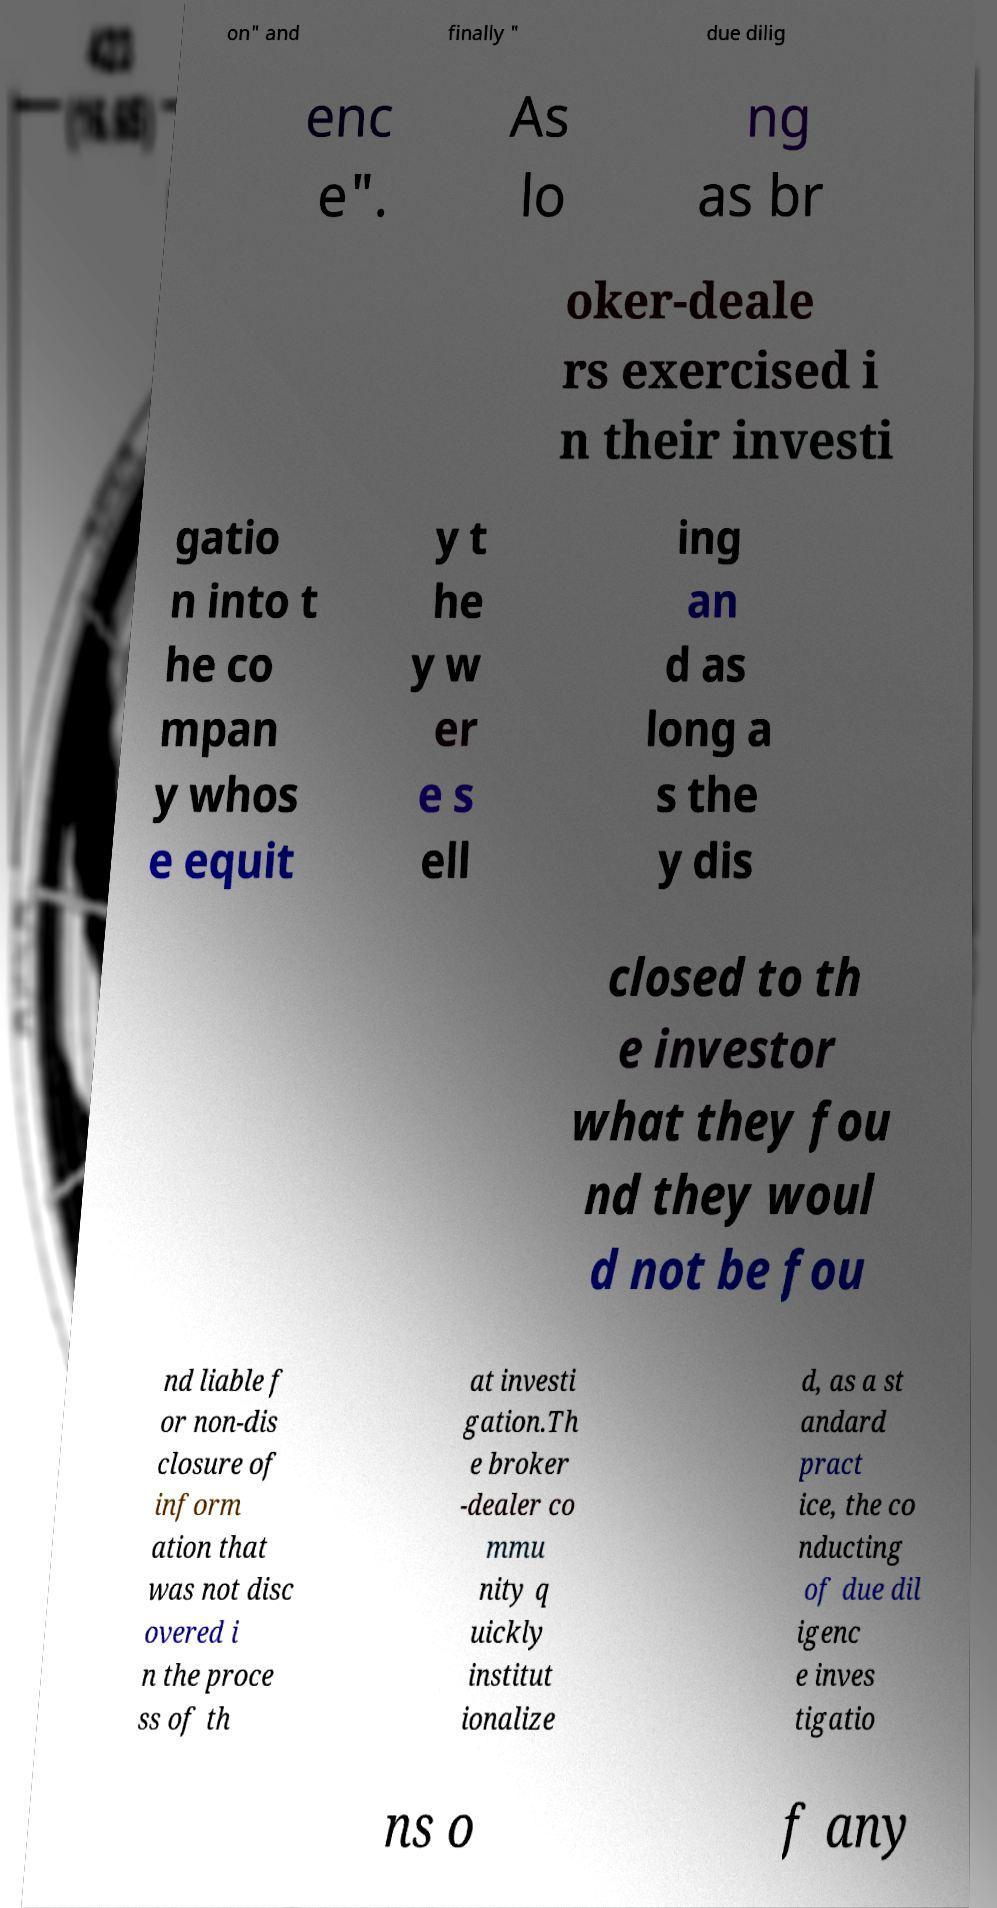Please identify and transcribe the text found in this image. on" and finally " due dilig enc e". As lo ng as br oker-deale rs exercised i n their investi gatio n into t he co mpan y whos e equit y t he y w er e s ell ing an d as long a s the y dis closed to th e investor what they fou nd they woul d not be fou nd liable f or non-dis closure of inform ation that was not disc overed i n the proce ss of th at investi gation.Th e broker -dealer co mmu nity q uickly institut ionalize d, as a st andard pract ice, the co nducting of due dil igenc e inves tigatio ns o f any 